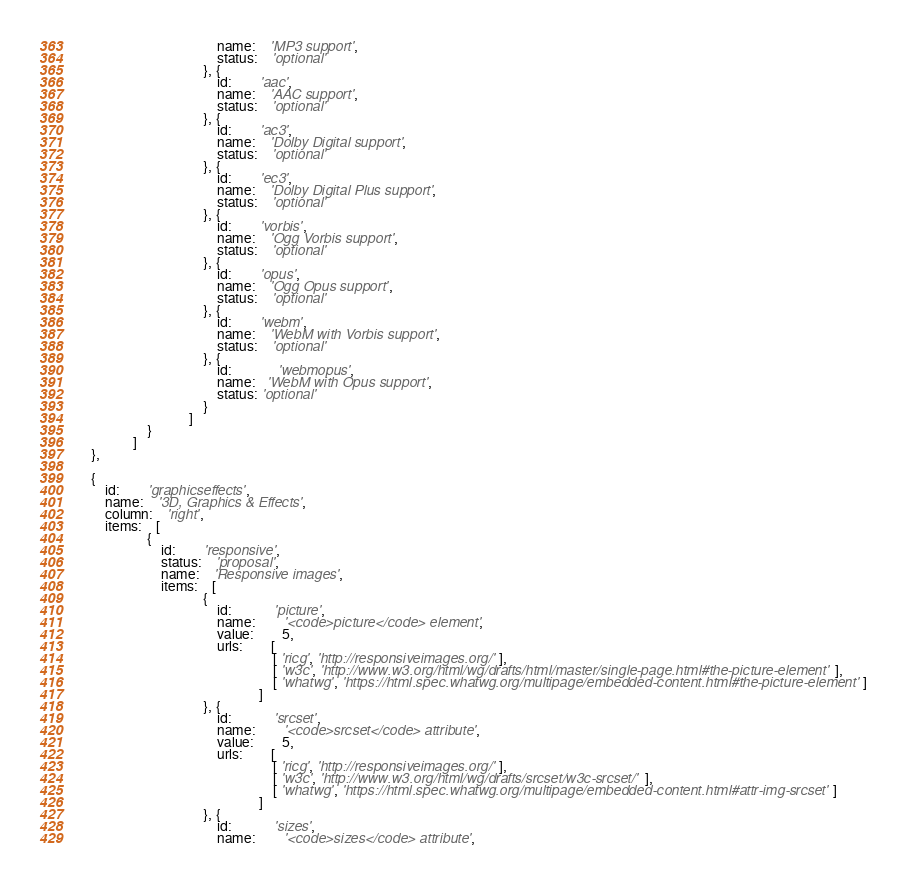Convert code to text. <code><loc_0><loc_0><loc_500><loc_500><_JavaScript_>										name: 	'MP3 support',
										status:	'optional'
									}, {
										id:		'aac',
										name: 	'AAC support',
										status:	'optional'
									}, {
										id:		'ac3',
										name: 	'Dolby Digital support',
										status:	'optional'
									}, {
										id:		'ec3',
										name: 	'Dolby Digital Plus support',
										status:	'optional'
									}, {
										id:		'vorbis',
										name: 	'Ogg Vorbis support',
										status:	'optional'
									}, {
										id:		'opus',
										name: 	'Ogg Opus support',
										status:	'optional'
									}, {
										id:		'webm',
										name: 	'WebM with Vorbis support',
										status:	'optional'
									}, {
                                        id:             'webmopus',
                                        name:   'WebM with Opus support',
                                        status: 'optional'
									}
								]
					}
				]
	},

	{
		id:		'graphicseffects',
		name:	'3D, Graphics & Effects',
		column:	'right',
		items:	[
					{
						id:		'responsive',
						status:	'proposal',
						name: 	'Responsive images',
						items:	[
									{
										id:			'picture',
										name: 		'<code>picture</code> element',
										value:		5,
										urls:		[
														[ 'ricg', 'http://responsiveimages.org/' ],
														[ 'w3c', 'http://www.w3.org/html/wg/drafts/html/master/single-page.html#the-picture-element' ],
														[ 'whatwg', 'https://html.spec.whatwg.org/multipage/embedded-content.html#the-picture-element' ]
													]
									}, {
										id:			'srcset',
										name: 		'<code>srcset</code> attribute',
										value:		5,
										urls:		[
														[ 'ricg', 'http://responsiveimages.org/' ],
														[ 'w3c', 'http://www.w3.org/html/wg/drafts/srcset/w3c-srcset/' ],
														[ 'whatwg', 'https://html.spec.whatwg.org/multipage/embedded-content.html#attr-img-srcset' ]
													]
									}, {
										id:			'sizes',
										name: 		'<code>sizes</code> attribute',</code> 